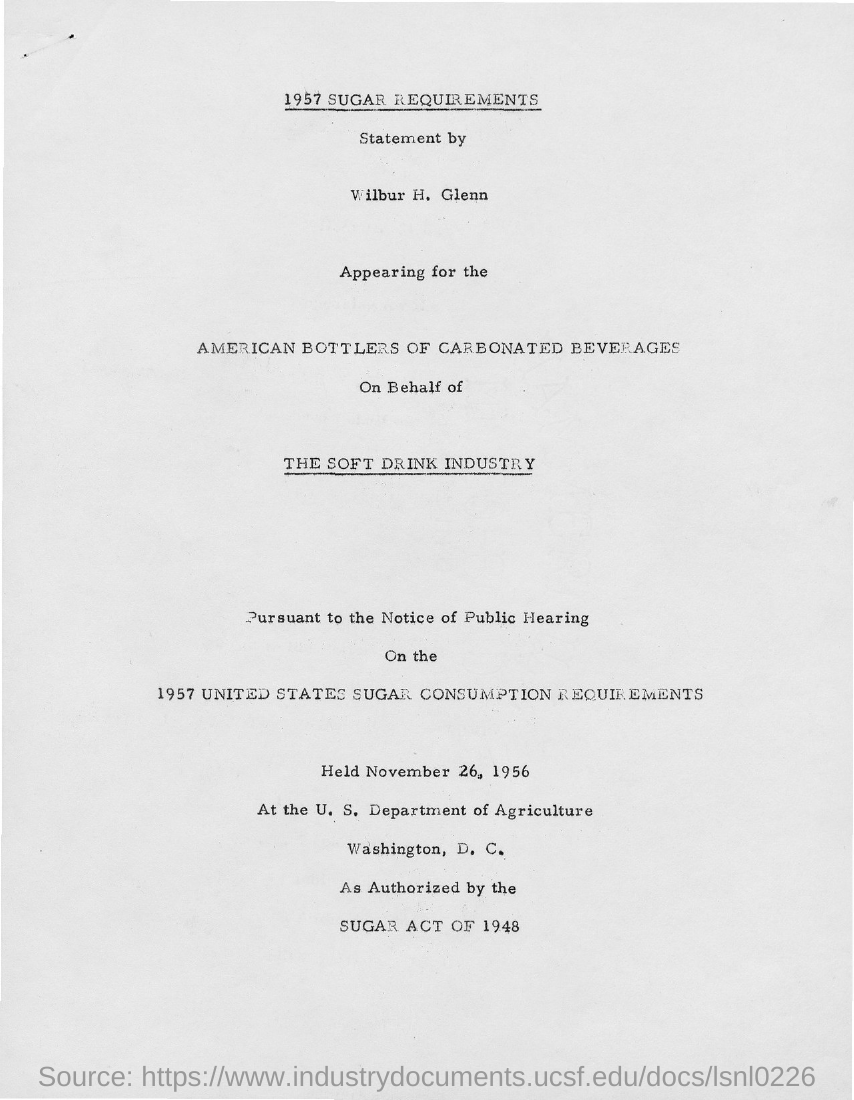What is the first title with an underline?
Ensure brevity in your answer.  1957 sugar requirements. 